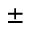Convert formula to latex. <formula><loc_0><loc_0><loc_500><loc_500>\pm</formula> 